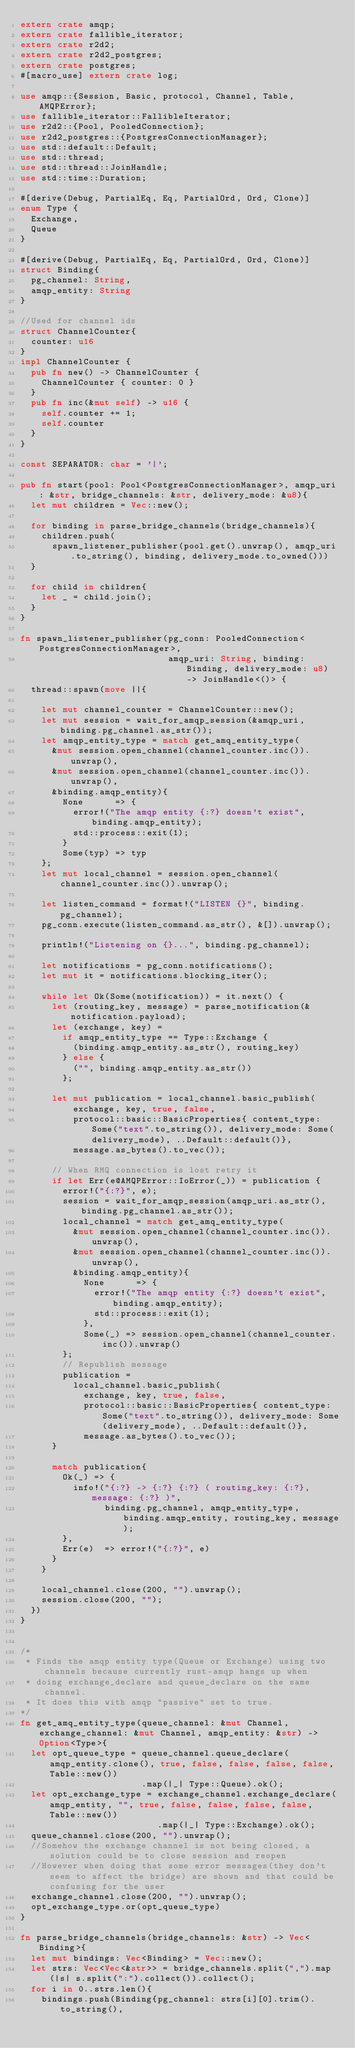<code> <loc_0><loc_0><loc_500><loc_500><_Rust_>extern crate amqp;
extern crate fallible_iterator;
extern crate r2d2;
extern crate r2d2_postgres;
extern crate postgres;
#[macro_use] extern crate log;

use amqp::{Session, Basic, protocol, Channel, Table, AMQPError};
use fallible_iterator::FallibleIterator;
use r2d2::{Pool, PooledConnection};
use r2d2_postgres::{PostgresConnectionManager};
use std::default::Default;
use std::thread;
use std::thread::JoinHandle;
use std::time::Duration;

#[derive(Debug, PartialEq, Eq, PartialOrd, Ord, Clone)]
enum Type {
  Exchange,
  Queue
}

#[derive(Debug, PartialEq, Eq, PartialOrd, Ord, Clone)]
struct Binding{
  pg_channel: String,
  amqp_entity: String
}

//Used for channel ids
struct ChannelCounter{
  counter: u16
}
impl ChannelCounter {
  pub fn new() -> ChannelCounter {
    ChannelCounter { counter: 0 }
  }
  pub fn inc(&mut self) -> u16 {
    self.counter += 1;
    self.counter
  }
}

const SEPARATOR: char = '|';

pub fn start(pool: Pool<PostgresConnectionManager>, amqp_uri: &str, bridge_channels: &str, delivery_mode: &u8){
  let mut children = Vec::new();

  for binding in parse_bridge_channels(bridge_channels){
    children.push(
      spawn_listener_publisher(pool.get().unwrap(), amqp_uri.to_string(), binding, delivery_mode.to_owned()))
  }

  for child in children{
    let _ = child.join();
  }
}

fn spawn_listener_publisher(pg_conn: PooledConnection<PostgresConnectionManager>,
                            amqp_uri: String, binding: Binding, delivery_mode: u8) -> JoinHandle<()> {
  thread::spawn(move ||{

    let mut channel_counter = ChannelCounter::new();
    let mut session = wait_for_amqp_session(&amqp_uri, binding.pg_channel.as_str());
    let amqp_entity_type = match get_amq_entity_type(
      &mut session.open_channel(channel_counter.inc()).unwrap(),
      &mut session.open_channel(channel_counter.inc()).unwrap(),
      &binding.amqp_entity){
        None      => {
          error!("The amqp entity {:?} doesn't exist", binding.amqp_entity);
          std::process::exit(1);
        }
        Some(typ) => typ
    };
    let mut local_channel = session.open_channel(channel_counter.inc()).unwrap();

    let listen_command = format!("LISTEN {}", binding.pg_channel);
    pg_conn.execute(listen_command.as_str(), &[]).unwrap();

    println!("Listening on {}...", binding.pg_channel);

    let notifications = pg_conn.notifications();
    let mut it = notifications.blocking_iter();

    while let Ok(Some(notification)) = it.next() {
      let (routing_key, message) = parse_notification(&notification.payload);
      let (exchange, key) =
        if amqp_entity_type == Type::Exchange {
          (binding.amqp_entity.as_str(), routing_key)
        } else {
          ("", binding.amqp_entity.as_str())
        };

      let mut publication = local_channel.basic_publish(
          exchange, key, true, false,
          protocol::basic::BasicProperties{ content_type: Some("text".to_string()), delivery_mode: Some(delivery_mode), ..Default::default()},
          message.as_bytes().to_vec());

      // When RMQ connection is lost retry it
      if let Err(e@AMQPError::IoError(_)) = publication {
        error!("{:?}", e);
        session = wait_for_amqp_session(amqp_uri.as_str(), binding.pg_channel.as_str());
        local_channel = match get_amq_entity_type(
          &mut session.open_channel(channel_counter.inc()).unwrap(),
          &mut session.open_channel(channel_counter.inc()).unwrap(),
          &binding.amqp_entity){
            None      => {
              error!("The amqp entity {:?} doesn't exist", binding.amqp_entity);
              std::process::exit(1);
            },
            Some(_) => session.open_channel(channel_counter.inc()).unwrap()
        };
        // Republish message
        publication =
          local_channel.basic_publish(
            exchange, key, true, false,
            protocol::basic::BasicProperties{ content_type: Some("text".to_string()), delivery_mode: Some(delivery_mode), ..Default::default()},
            message.as_bytes().to_vec());
      }

      match publication{
        Ok(_) => {
          info!("{:?} -> {:?} {:?} ( routing_key: {:?}, message: {:?} )",
                binding.pg_channel, amqp_entity_type, binding.amqp_entity, routing_key, message);
        },
        Err(e)  => error!("{:?}", e)
      }
    }

    local_channel.close(200, "").unwrap();
    session.close(200, "");
  })
}


/*
 * Finds the amqp entity type(Queue or Exchange) using two channels because currently rust-amqp hangs up when
 * doing exchange_declare and queue_declare on the same channel.
 * It does this with amqp "passive" set to true.
*/
fn get_amq_entity_type(queue_channel: &mut Channel, exchange_channel: &mut Channel, amqp_entity: &str) -> Option<Type>{
  let opt_queue_type = queue_channel.queue_declare(amqp_entity.clone(), true, false, false, false, false, Table::new())
                       .map(|_| Type::Queue).ok();
  let opt_exchange_type = exchange_channel.exchange_declare(amqp_entity, "", true, false, false, false, false, Table::new())
                          .map(|_| Type::Exchange).ok();
  queue_channel.close(200, "").unwrap();
  //Somehow the exchange channel is not being closed, a solution could be to close session and reopen
  //However when doing that some error messages(they don't seem to affect the bridge) are shown and that could be confusing for the user
  exchange_channel.close(200, "").unwrap();
  opt_exchange_type.or(opt_queue_type)
}

fn parse_bridge_channels(bridge_channels: &str) -> Vec<Binding>{
  let mut bindings: Vec<Binding> = Vec::new();
  let strs: Vec<Vec<&str>> = bridge_channels.split(",").map(|s| s.split(":").collect()).collect();
  for i in 0..strs.len(){
    bindings.push(Binding{pg_channel: strs[i][0].trim().to_string(),</code> 